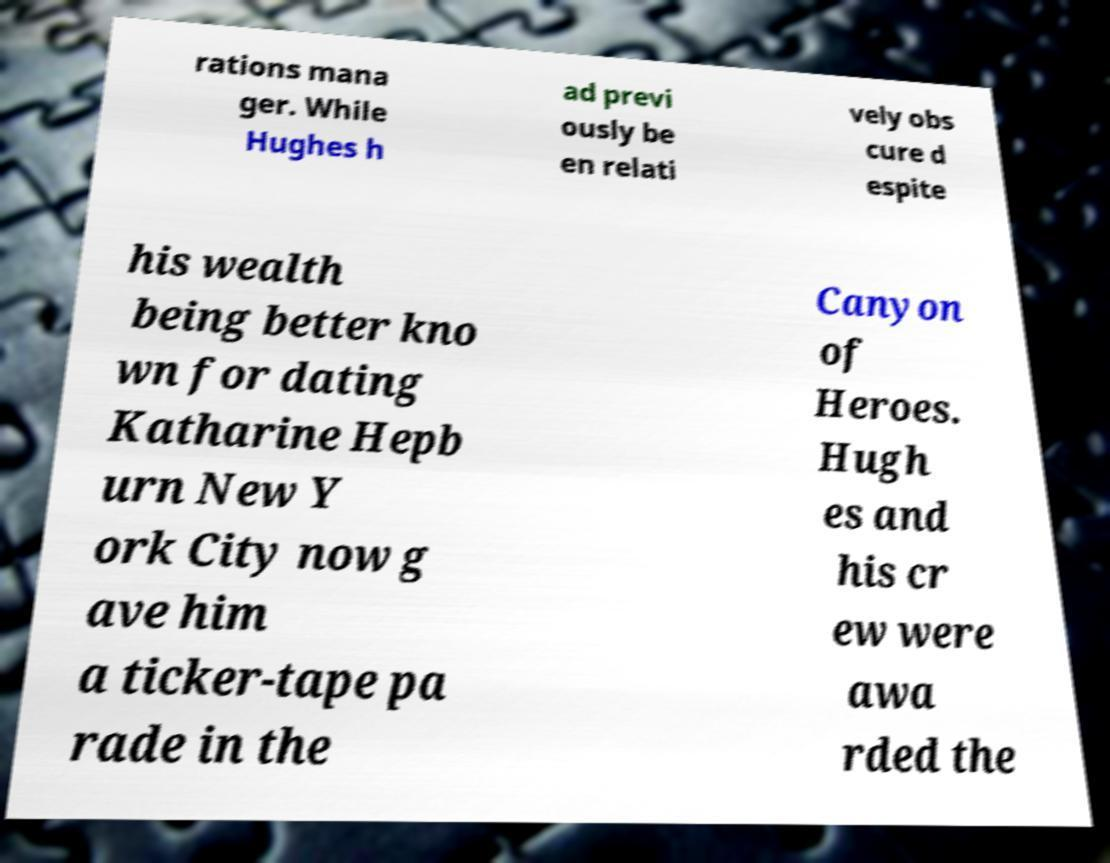Please read and relay the text visible in this image. What does it say? rations mana ger. While Hughes h ad previ ously be en relati vely obs cure d espite his wealth being better kno wn for dating Katharine Hepb urn New Y ork City now g ave him a ticker-tape pa rade in the Canyon of Heroes. Hugh es and his cr ew were awa rded the 